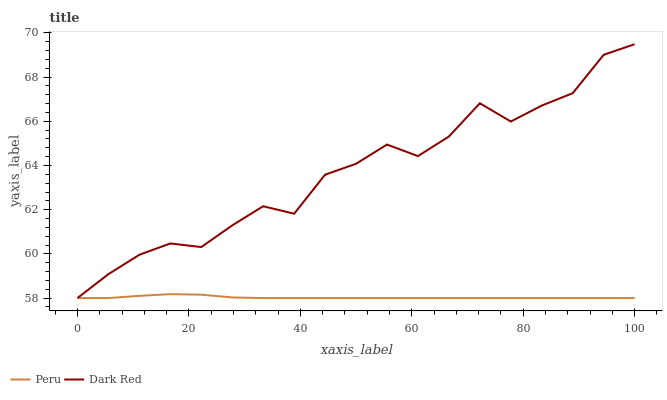Does Peru have the minimum area under the curve?
Answer yes or no. Yes. Does Dark Red have the maximum area under the curve?
Answer yes or no. Yes. Does Peru have the maximum area under the curve?
Answer yes or no. No. Is Peru the smoothest?
Answer yes or no. Yes. Is Dark Red the roughest?
Answer yes or no. Yes. Is Peru the roughest?
Answer yes or no. No. Does Peru have the highest value?
Answer yes or no. No. 